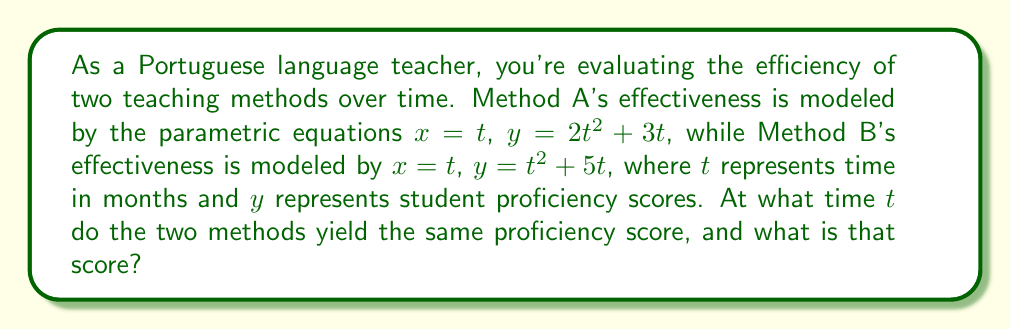Give your solution to this math problem. To solve this problem, we need to follow these steps:

1) The methods yield the same proficiency score when their $y$ values are equal. So, we set up the equation:

   $2t^2 + 3t = t^2 + 5t$

2) Simplify the equation:

   $2t^2 + 3t - (t^2 + 5t) = 0$
   $t^2 - 2t = 0$

3) Factor out the common factor:

   $t(t - 2) = 0$

4) Solve for $t$:

   $t = 0$ or $t = 2$

   Since $t$ represents time, we discard the $t = 0$ solution as it doesn't make sense in this context.

5) Therefore, the methods yield the same score at $t = 2$ months.

6) To find the score at this time, we can use either method's equations. Let's use Method A:

   $x = t = 2$
   $y = 2t^2 + 3t = 2(2)^2 + 3(2) = 8 + 6 = 14$

Thus, at $t = 2$ months, both methods yield a proficiency score of 14.
Answer: The two methods yield the same proficiency score after 2 months, and the score at that time is 14. 